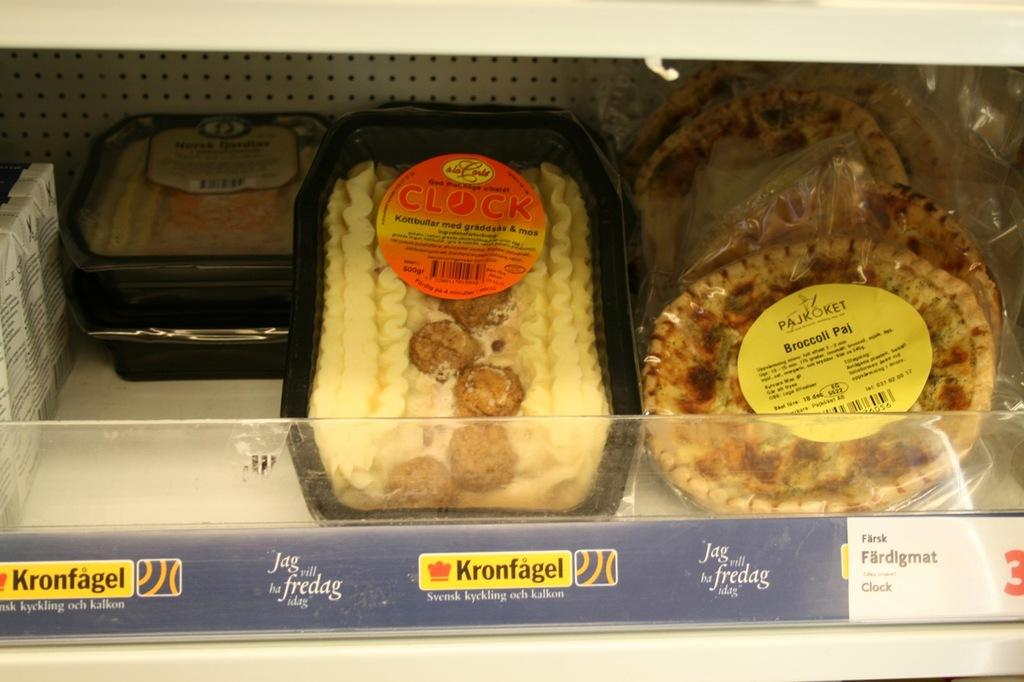What type of items are in the boxes that are visible in the image? The boxes contain eatable items. Where are the boxes located in the image? The boxes are kept on shelves. How many lights are present in the image? There is no information about lights in the image, as the facts only mention eatable item boxes and their location on shelves. 